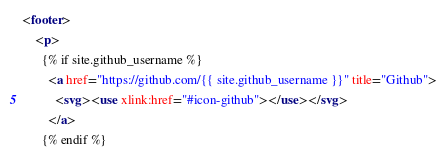Convert code to text. <code><loc_0><loc_0><loc_500><loc_500><_HTML_><footer>
    <p>
      {% if site.github_username %}
        <a href="https://github.com/{{ site.github_username }}" title="Github">
          <svg><use xlink:href="#icon-github"></use></svg>
        </a>
      {% endif %}</code> 